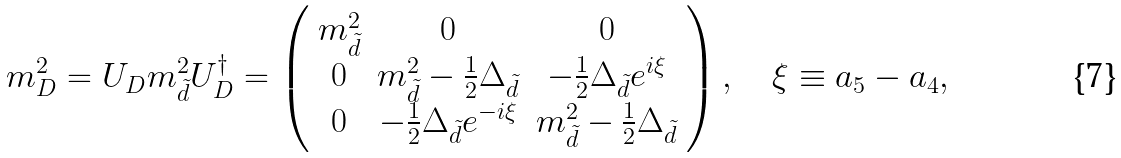<formula> <loc_0><loc_0><loc_500><loc_500>m _ { D } ^ { 2 } = U _ { D } m _ { \tilde { d } } ^ { 2 } U _ { D } ^ { \dagger } = \left ( \begin{array} { c c c } m _ { \tilde { d } } ^ { 2 } & 0 & 0 \\ 0 & m _ { \tilde { d } } ^ { 2 } - \frac { 1 } { 2 } \Delta _ { \tilde { d } } & - \frac { 1 } { 2 } \Delta _ { \tilde { d } } e ^ { i \xi } \\ 0 & - \frac { 1 } { 2 } \Delta _ { \tilde { d } } e ^ { - i \xi } & m _ { \tilde { d } } ^ { 2 } - \frac { 1 } { 2 } \Delta _ { \tilde { d } } \end{array} \right ) , \quad \xi \equiv a _ { 5 } - a _ { 4 } ,</formula> 